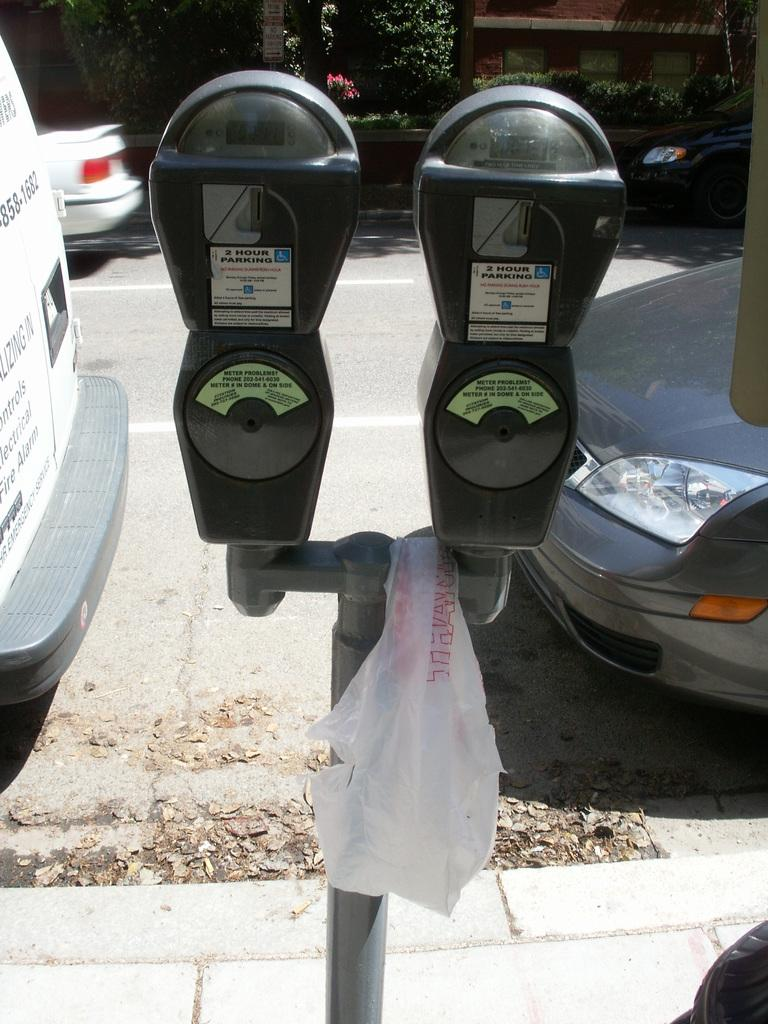<image>
Offer a succinct explanation of the picture presented. two meters for 2 hour parking on the side of the street 